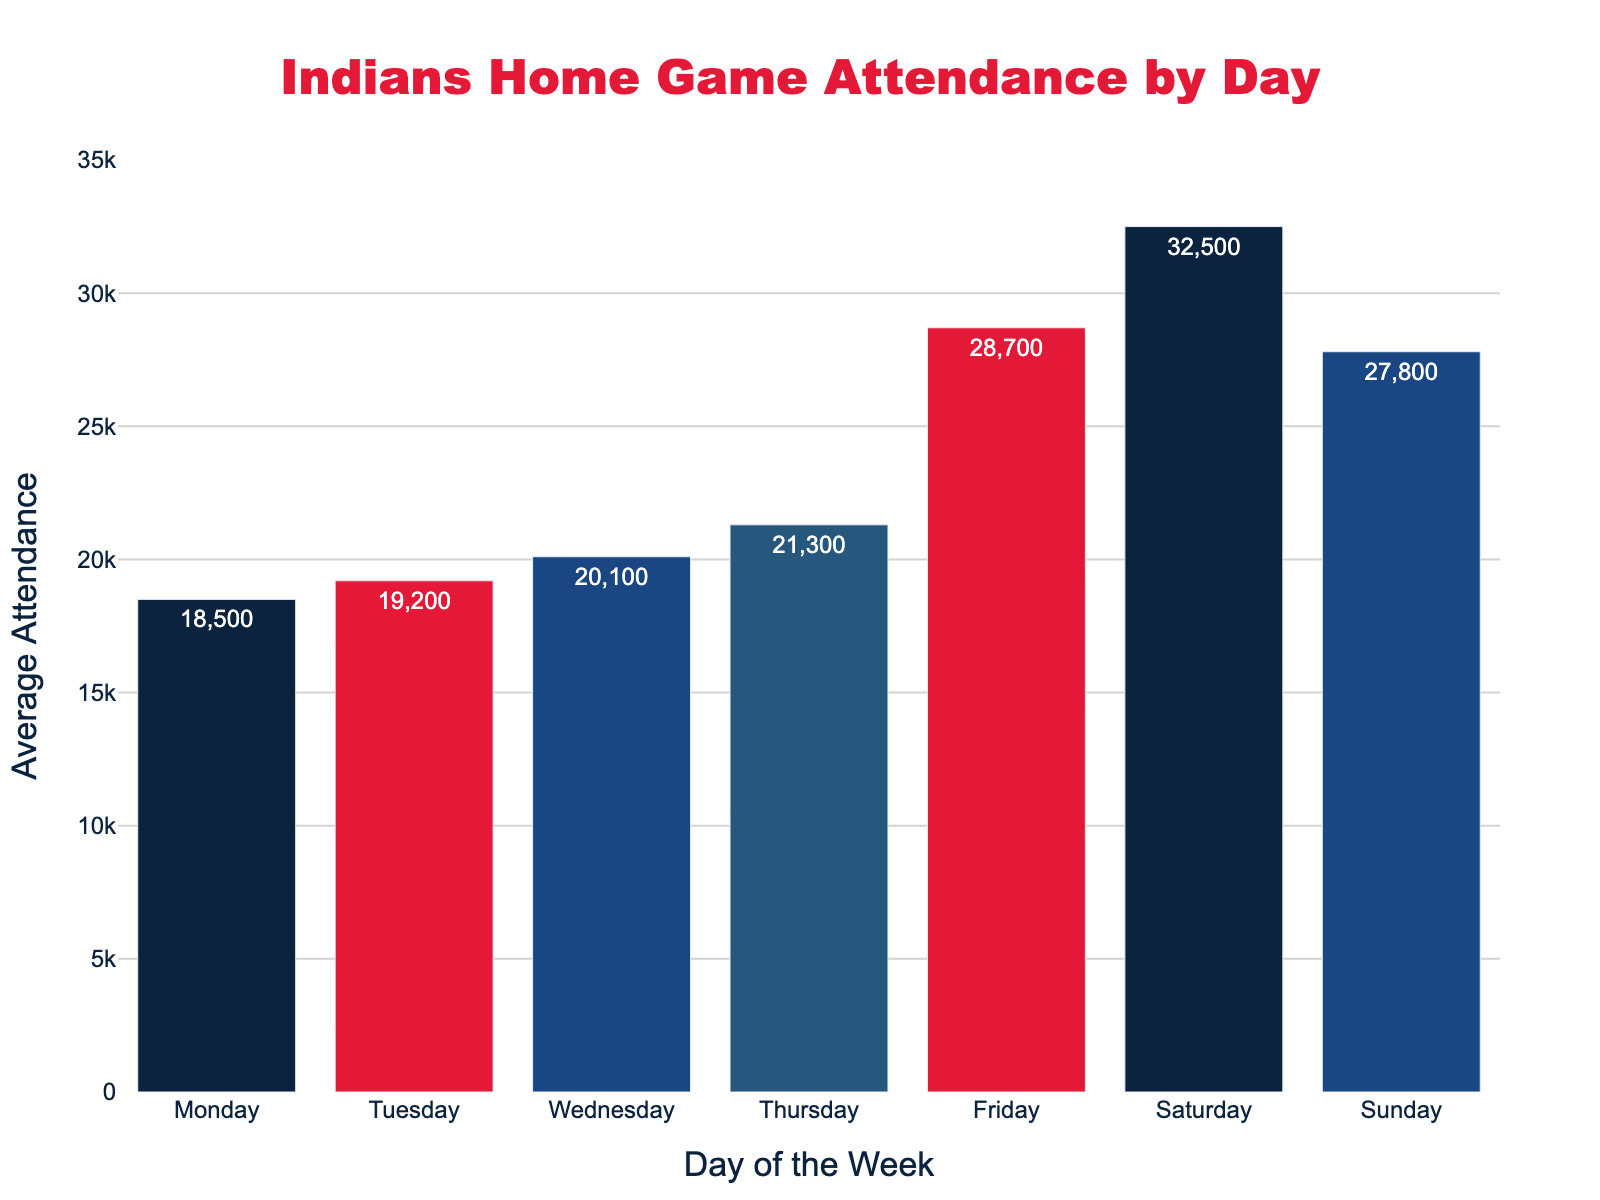What's the average attendance for Friday games? The bar for Friday indicates the average attendance number.
Answer: 28,700 Which day has the highest average attendance? Look for the tallest bar. The tallest bar corresponds to Saturday.
Answer: Saturday How much higher is the average attendance on Saturday compared to Tuesday? Find the heights of the bars on Saturday and Tuesday and subtract the Tuesday value from the Saturday value (32,500 - 19,200).
Answer: 13,300 Which days have an average attendance greater than 20,000? Identify the bars that reach above the 20,000 mark. These are Wednesday, Thursday, Friday, Saturday, and Sunday.
Answer: Wednesday, Thursday, Friday, Saturday, Sunday Is the average attendance on Monday higher or lower than on Thursday? Compare the heights of the Monday and Thursday bars. The Monday bar is shorter than the Thursday bar.
Answer: Lower What's the difference in average attendance between the highest and lowest days? Find the heights of the tallest and shortest bars, then subtract the lowest value from the highest (32,500 - 18,500).
Answer: 14,000 What is the average attendance on weekdays (Monday to Friday) compared to weekends (Saturday and Sunday)? Calculate the average of Monday, Tuesday, Wednesday, Thursday, and Friday numbers, and then the average of Saturday and Sunday numbers. Weekdays: (18,500 + 19,200 + 20,100 + 21,300 + 28,700) / 5 = 21,560. Weekends: (32,500 + 27,800) / 2 = 30,150.
Answer: Weekdays: 21,560, Weekends: 30,150 Which day has the lowest average attendance? Look for the shortest bar. The shortest bar corresponds to Monday.
Answer: Monday How does the average attendance on Wednesday compare to Thursday? Compare the heights of the Wednesday and Thursday bars. The Wednesday bar is shorter than the Thursday bar.
Answer: Lower What is the combined average attendance for Monday and Tuesday? Add the average attendance of Monday and Tuesday (18,500 + 19,200).
Answer: 37,700 